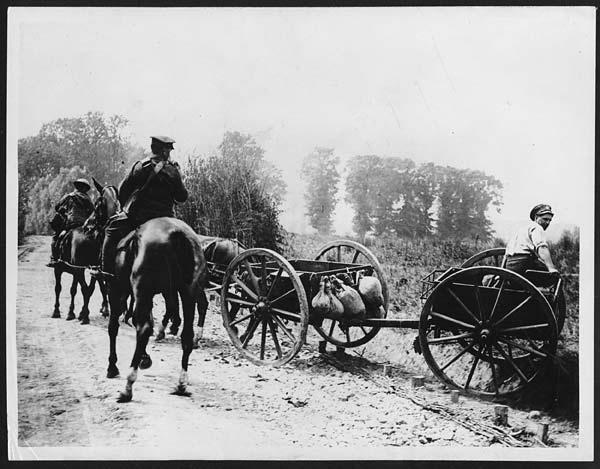Is the wagon overloaded?
Keep it brief. No. What event is taking place here?
Keep it brief. Traveling. What are these horses pulling?
Keep it brief. Wagons. Are the wheels rubber?
Quick response, please. No. IS this photo modern or historical?
Short answer required. Historical. 